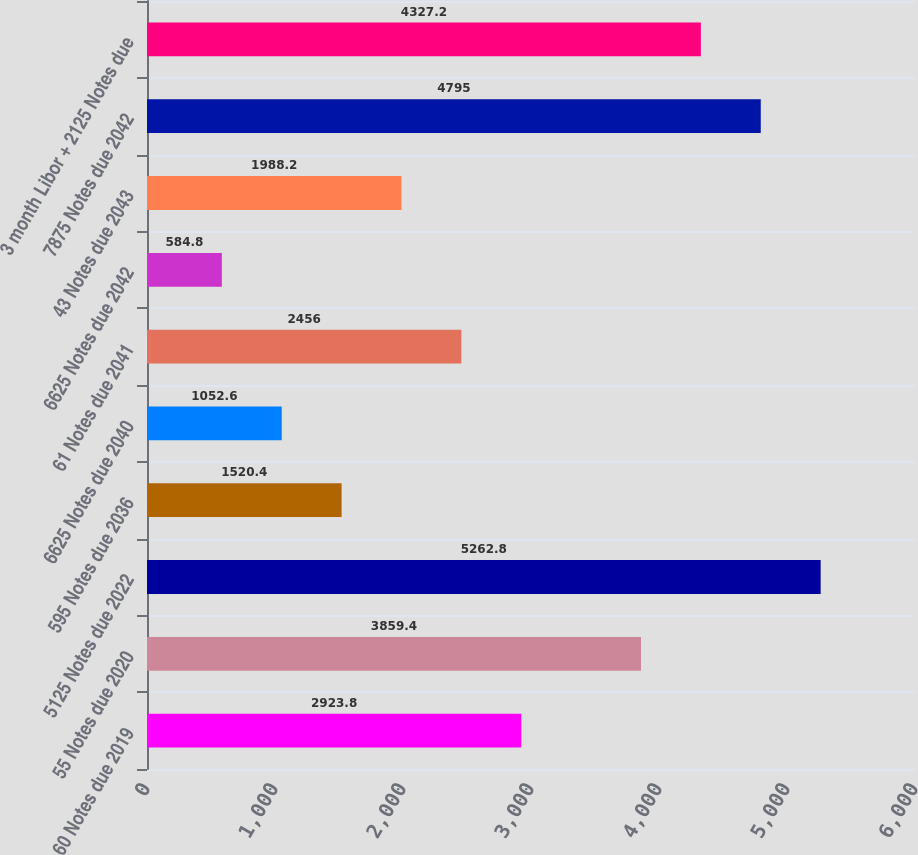Convert chart. <chart><loc_0><loc_0><loc_500><loc_500><bar_chart><fcel>60 Notes due 2019<fcel>55 Notes due 2020<fcel>5125 Notes due 2022<fcel>595 Notes due 2036<fcel>6625 Notes due 2040<fcel>61 Notes due 2041<fcel>6625 Notes due 2042<fcel>43 Notes due 2043<fcel>7875 Notes due 2042<fcel>3 month Libor + 2125 Notes due<nl><fcel>2923.8<fcel>3859.4<fcel>5262.8<fcel>1520.4<fcel>1052.6<fcel>2456<fcel>584.8<fcel>1988.2<fcel>4795<fcel>4327.2<nl></chart> 